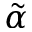Convert formula to latex. <formula><loc_0><loc_0><loc_500><loc_500>\tilde { \alpha }</formula> 